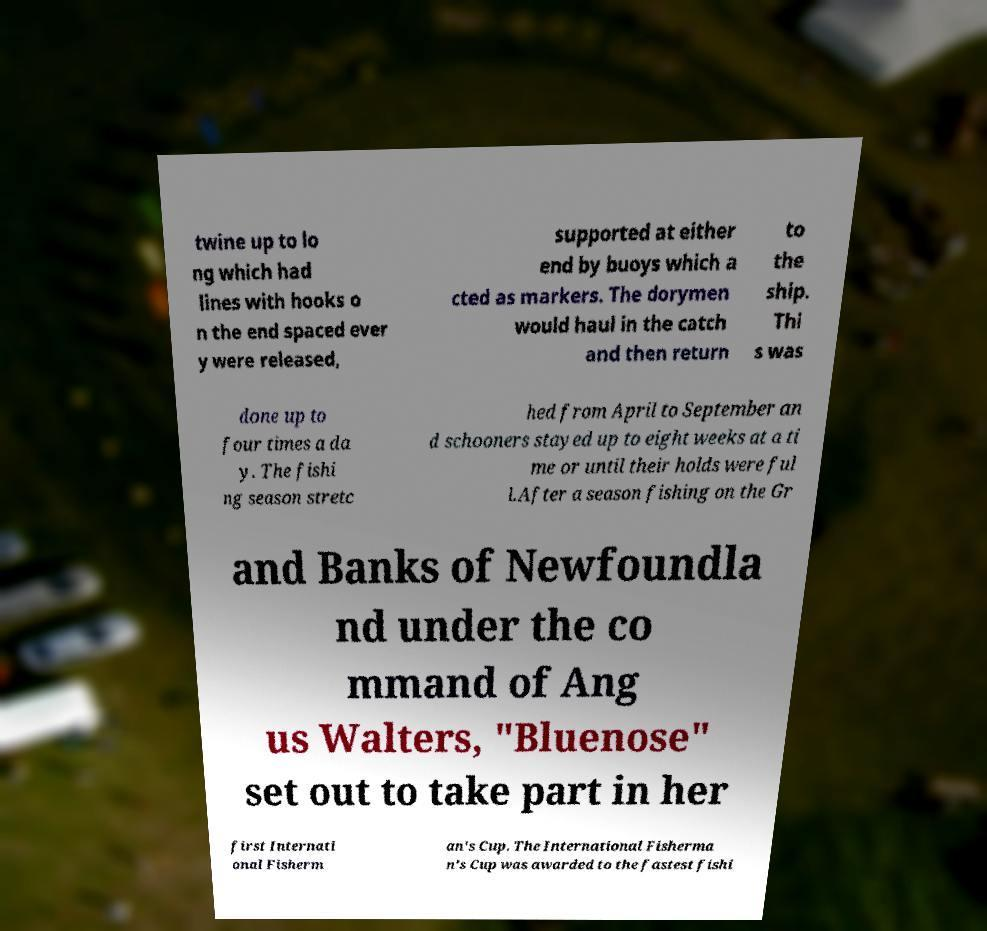I need the written content from this picture converted into text. Can you do that? twine up to lo ng which had lines with hooks o n the end spaced ever y were released, supported at either end by buoys which a cted as markers. The dorymen would haul in the catch and then return to the ship. Thi s was done up to four times a da y. The fishi ng season stretc hed from April to September an d schooners stayed up to eight weeks at a ti me or until their holds were ful l.After a season fishing on the Gr and Banks of Newfoundla nd under the co mmand of Ang us Walters, "Bluenose" set out to take part in her first Internati onal Fisherm an's Cup. The International Fisherma n's Cup was awarded to the fastest fishi 